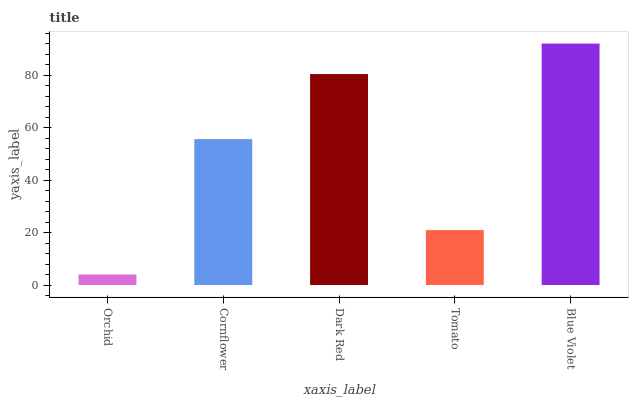Is Orchid the minimum?
Answer yes or no. Yes. Is Blue Violet the maximum?
Answer yes or no. Yes. Is Cornflower the minimum?
Answer yes or no. No. Is Cornflower the maximum?
Answer yes or no. No. Is Cornflower greater than Orchid?
Answer yes or no. Yes. Is Orchid less than Cornflower?
Answer yes or no. Yes. Is Orchid greater than Cornflower?
Answer yes or no. No. Is Cornflower less than Orchid?
Answer yes or no. No. Is Cornflower the high median?
Answer yes or no. Yes. Is Cornflower the low median?
Answer yes or no. Yes. Is Dark Red the high median?
Answer yes or no. No. Is Blue Violet the low median?
Answer yes or no. No. 